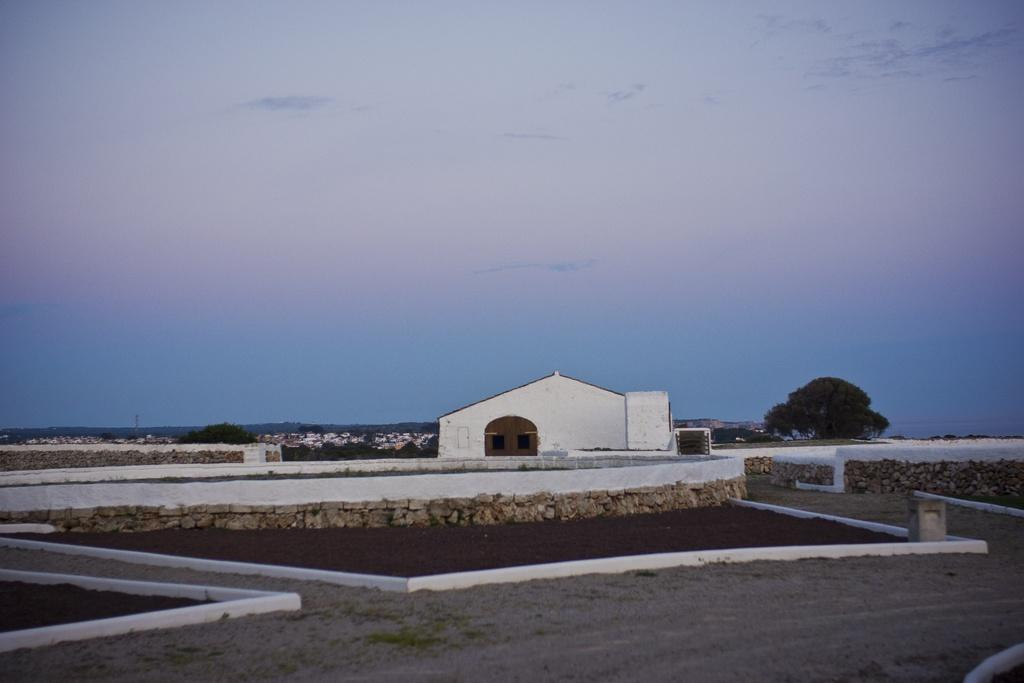What type of area is visible in the image? There is an open area in the image. What structures can be seen in the image? There is a stonewall and a house in the image. What can be seen in the background of the image? There are trees, houses, and a clear sky visible in the background of the image. What type of crook is present in the image? There is no crook present in the image. What angle is the house leaning at in the image? The house is not leaning in the image; it appears to be standing upright. 